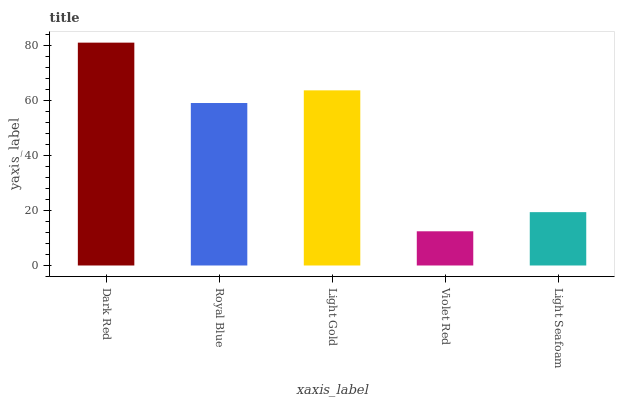Is Violet Red the minimum?
Answer yes or no. Yes. Is Dark Red the maximum?
Answer yes or no. Yes. Is Royal Blue the minimum?
Answer yes or no. No. Is Royal Blue the maximum?
Answer yes or no. No. Is Dark Red greater than Royal Blue?
Answer yes or no. Yes. Is Royal Blue less than Dark Red?
Answer yes or no. Yes. Is Royal Blue greater than Dark Red?
Answer yes or no. No. Is Dark Red less than Royal Blue?
Answer yes or no. No. Is Royal Blue the high median?
Answer yes or no. Yes. Is Royal Blue the low median?
Answer yes or no. Yes. Is Light Seafoam the high median?
Answer yes or no. No. Is Light Seafoam the low median?
Answer yes or no. No. 